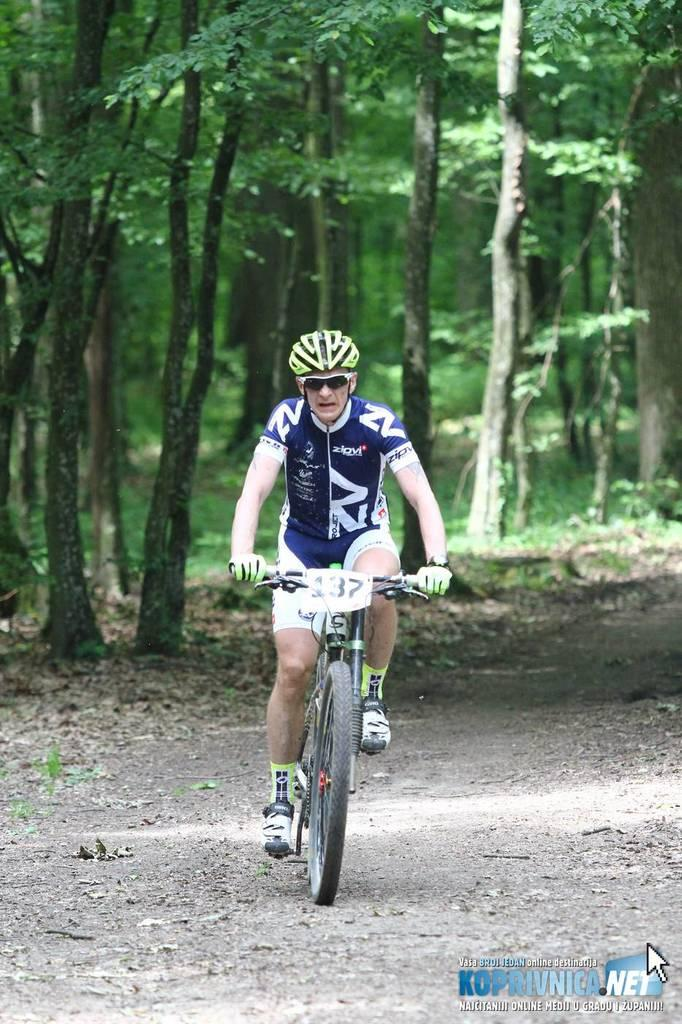What is the main subject of the image? There is a person in the image. What is the person doing in the image? The person is riding a bicycle. What is the position of the bicycle in the image? The bicycle is on the ground. What can be seen in the background of the image? There are trees in the background of the image. What type of linen can be seen draped over the bicycle in the image? There is no linen present in the image; it only features a person riding a bicycle with trees in the background. 